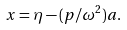Convert formula to latex. <formula><loc_0><loc_0><loc_500><loc_500>x = \eta - ( p / \omega ^ { 2 } ) a .</formula> 